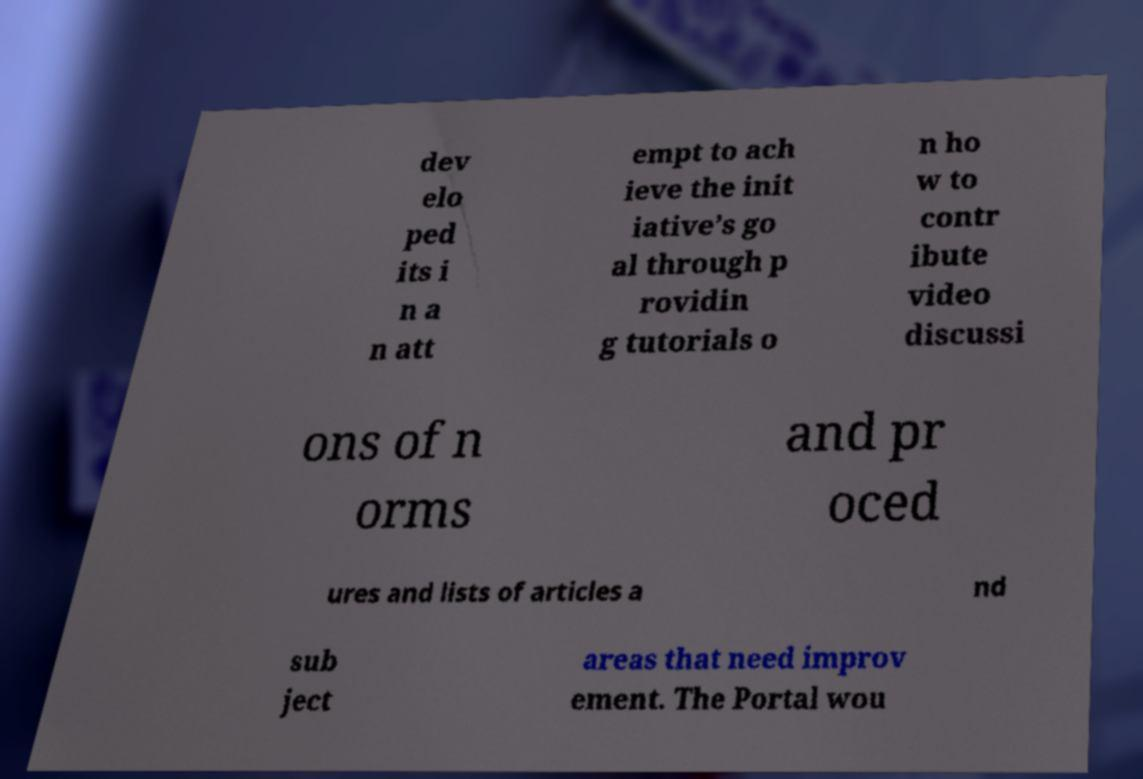There's text embedded in this image that I need extracted. Can you transcribe it verbatim? dev elo ped its i n a n att empt to ach ieve the init iative’s go al through p rovidin g tutorials o n ho w to contr ibute video discussi ons of n orms and pr oced ures and lists of articles a nd sub ject areas that need improv ement. The Portal wou 